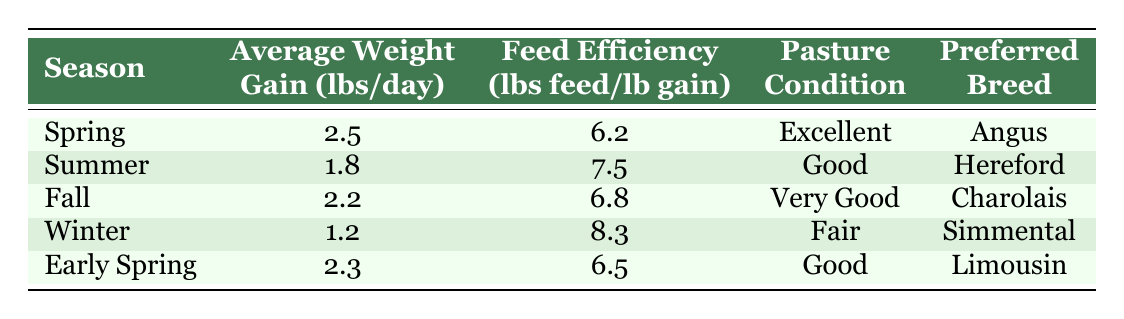What is the average weight gain during the Fall season? From the table, the average weight gain during the Fall season is directly listed as 2.2 lbs/day.
Answer: 2.2 lbs/day Which season has the best pasture condition? The best pasture condition listed in the table is "Excellent," which corresponds to the Spring season.
Answer: Spring What is the average feed efficiency for the Winter season? According to the table, the feed efficiency for the Winter season is 8.3 lbs feed/lb gain, as shown in the corresponding row.
Answer: 8.3 lbs feed/lb gain How much more weight do cattle gain on average in Spring compared to Winter? In Spring, the average weight gain is 2.5 lbs/day, and in Winter, it's 1.2 lbs/day. The difference is calculated as 2.5 - 1.2 = 1.3 lbs/day.
Answer: 1.3 lbs/day Is the Angus breed preferred in the Summer season? The Angus breed is listed under the Spring season, and no breed is mentioned for the Summer season. Hence, the answer is no.
Answer: No What is the difference in feed efficiency between Summer and Fall? The feed efficiency for Summer is 7.5 lbs feed/lb gain, and for Fall, it’s 6.8 lbs feed/lb gain. The difference is 7.5 - 6.8 = 0.7 lbs feed/lb gain.
Answer: 0.7 lbs feed/lb gain Which season has the lowest average weight gain? The table shows that Winter has the lowest average weight gain at 1.2 lbs/day.
Answer: Winter What is the average weight gain across all seasons? To find the average weight gain, we first sum the average weight gains: 2.5 + 1.8 + 2.2 + 1.2 + 2.3 = 10.0 lbs/day for five seasons. Thus, the average is 10.0 / 5 = 2.0 lbs/day.
Answer: 2.0 lbs/day Which breed has the lowest feed efficiency? Simmental, preferred in Winter, has the lowest feed efficiency listed at 8.3 lbs feed/lb gain, based on the data in the table.
Answer: Simmental 